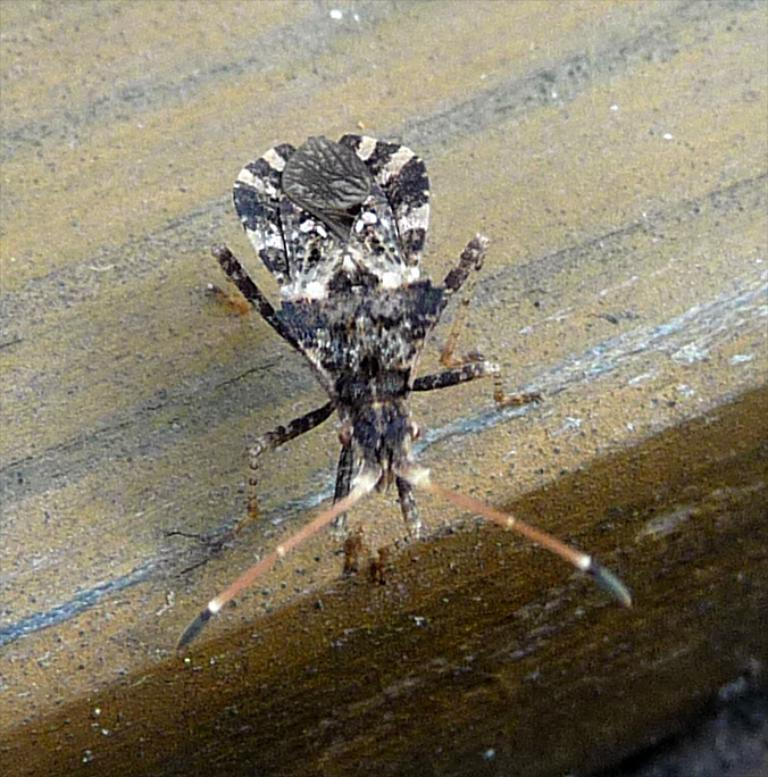What type of creature can be seen in the image? There is a flying insect in the image. How does the insect appear in the image? The insect looks like a wooden block. What type of juice is being served on the grass in the image? There is no juice or grass present in the image; it only features a flying insect that looks like a wooden block. 